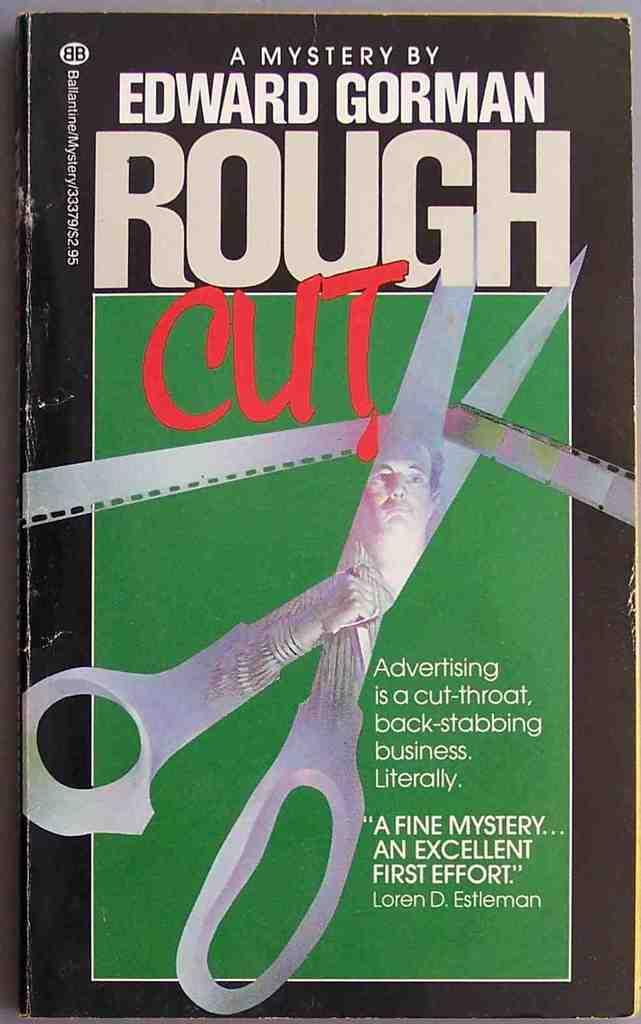<image>
Relay a brief, clear account of the picture shown. A book by Edward Gorman features a pair of scissors on the sover. 